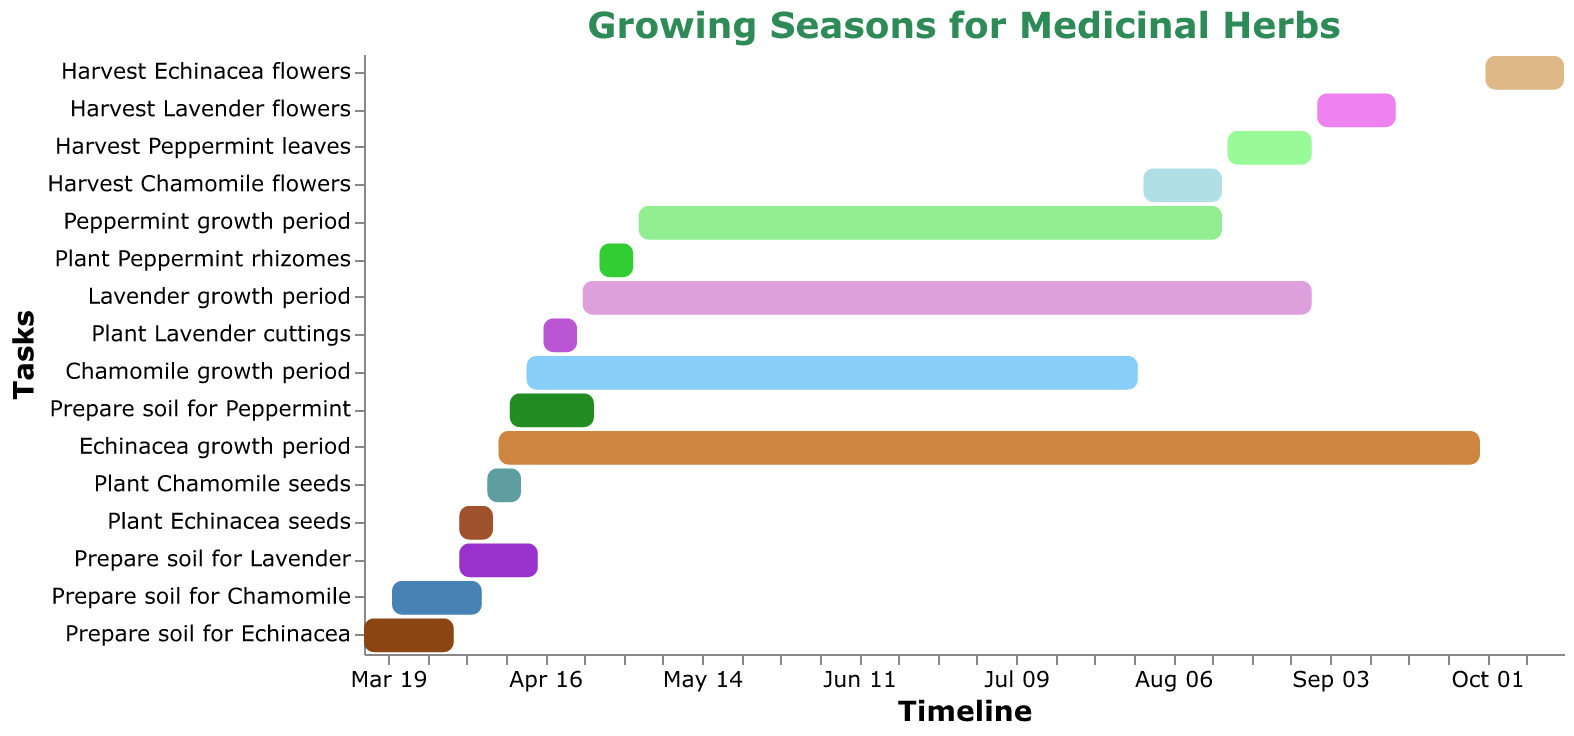When does the Echinacea growth period start and end? The Echinacea growth period starts on April 8, 2023, and ends on September 30, 2023. We identify these dates by looking at the bar labeled "Echinacea growth period" and noting the start and end dates.
Answer: April 8, 2023 - September 30, 2023 Which herb has the earliest harvesting period? By examining the harvest bars for each herb, we find that Chamomile has the earliest harvesting period starting on August 1, 2023, which is earlier than the other herbs' harvest periods.
Answer: Chamomile What is the duration of the Lavender growth period? The Lavender growth period starts on April 23, 2023, and ends on August 31, 2023. The duration is calculated by counting the number of days between these dates.
Answer: 131 days How many herbs have a growth period that lasts into September? By looking at the "growth period" bars, we see that Echinacea and Lavender have growth periods extending into September.
Answer: 2 herbs Compare the preparation times: Is the soil preparation for Peppermint longer or shorter than for Chamomile? The Peppermint soil preparation lasts from April 10 to April 25, 2023, totaling 15 days. The Chamomile soil preparation lasts from March 20 to April 5, 2023, totaling 16 days. Peppermint preparation is 1 day shorter.
Answer: Shorter What is the total number of days from planting to harvesting for Chamomile? Chamomile is planted from April 6 to April 12, 2023, and harvested from August 1 to August 15, 2023. Calculating the entire period from the end of planting to the start of harvesting gives 112 days.
Answer: 112 days During which month do the majority of herb preparations (either planting or soil preparation) occur? The majority of the tasks related to soil preparation and planting for all herbs appear clustered mostly during April. By visually inspecting the start and end of each task.
Answer: April How long is the maintenance period (i.e., growth period) for Peppermint, and does it overlap with that of Lavender? The Peppermint growth period runs from May 3 to August 15, 2023, lasting 105 days. The Lavender growth period, from April 23 to August 31, 2023, overlaps with Peppermint from May 3 to August 15.
Answer: 105 days, Yes Which herb has the shortest overall timeline from the start of soil preparation to the end of harvesting? Chamomile has the shortest overall timeline from March 20, 2023, to August 15, 2023. This is found by looking at the start and end dates for soil preparation to harvest time for each herb.
Answer: Chamomile 